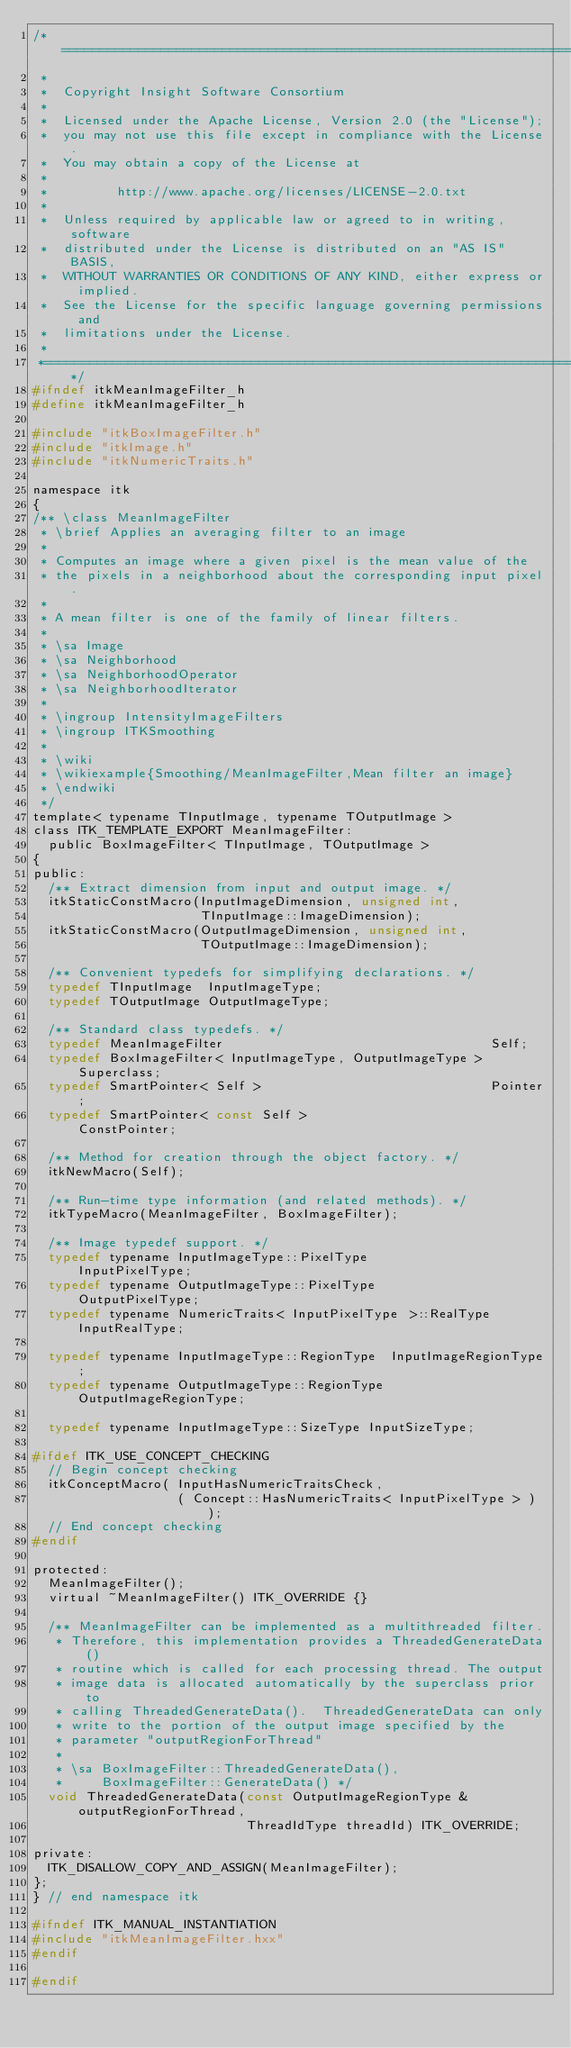<code> <loc_0><loc_0><loc_500><loc_500><_C_>/*=========================================================================
 *
 *  Copyright Insight Software Consortium
 *
 *  Licensed under the Apache License, Version 2.0 (the "License");
 *  you may not use this file except in compliance with the License.
 *  You may obtain a copy of the License at
 *
 *         http://www.apache.org/licenses/LICENSE-2.0.txt
 *
 *  Unless required by applicable law or agreed to in writing, software
 *  distributed under the License is distributed on an "AS IS" BASIS,
 *  WITHOUT WARRANTIES OR CONDITIONS OF ANY KIND, either express or implied.
 *  See the License for the specific language governing permissions and
 *  limitations under the License.
 *
 *=========================================================================*/
#ifndef itkMeanImageFilter_h
#define itkMeanImageFilter_h

#include "itkBoxImageFilter.h"
#include "itkImage.h"
#include "itkNumericTraits.h"

namespace itk
{
/** \class MeanImageFilter
 * \brief Applies an averaging filter to an image
 *
 * Computes an image where a given pixel is the mean value of the
 * the pixels in a neighborhood about the corresponding input pixel.
 *
 * A mean filter is one of the family of linear filters.
 *
 * \sa Image
 * \sa Neighborhood
 * \sa NeighborhoodOperator
 * \sa NeighborhoodIterator
 *
 * \ingroup IntensityImageFilters
 * \ingroup ITKSmoothing
 *
 * \wiki
 * \wikiexample{Smoothing/MeanImageFilter,Mean filter an image}
 * \endwiki
 */
template< typename TInputImage, typename TOutputImage >
class ITK_TEMPLATE_EXPORT MeanImageFilter:
  public BoxImageFilter< TInputImage, TOutputImage >
{
public:
  /** Extract dimension from input and output image. */
  itkStaticConstMacro(InputImageDimension, unsigned int,
                      TInputImage::ImageDimension);
  itkStaticConstMacro(OutputImageDimension, unsigned int,
                      TOutputImage::ImageDimension);

  /** Convenient typedefs for simplifying declarations. */
  typedef TInputImage  InputImageType;
  typedef TOutputImage OutputImageType;

  /** Standard class typedefs. */
  typedef MeanImageFilter                                   Self;
  typedef BoxImageFilter< InputImageType, OutputImageType > Superclass;
  typedef SmartPointer< Self >                              Pointer;
  typedef SmartPointer< const Self >                        ConstPointer;

  /** Method for creation through the object factory. */
  itkNewMacro(Self);

  /** Run-time type information (and related methods). */
  itkTypeMacro(MeanImageFilter, BoxImageFilter);

  /** Image typedef support. */
  typedef typename InputImageType::PixelType                 InputPixelType;
  typedef typename OutputImageType::PixelType                OutputPixelType;
  typedef typename NumericTraits< InputPixelType >::RealType InputRealType;

  typedef typename InputImageType::RegionType  InputImageRegionType;
  typedef typename OutputImageType::RegionType OutputImageRegionType;

  typedef typename InputImageType::SizeType InputSizeType;

#ifdef ITK_USE_CONCEPT_CHECKING
  // Begin concept checking
  itkConceptMacro( InputHasNumericTraitsCheck,
                   ( Concept::HasNumericTraits< InputPixelType > ) );
  // End concept checking
#endif

protected:
  MeanImageFilter();
  virtual ~MeanImageFilter() ITK_OVERRIDE {}

  /** MeanImageFilter can be implemented as a multithreaded filter.
   * Therefore, this implementation provides a ThreadedGenerateData()
   * routine which is called for each processing thread. The output
   * image data is allocated automatically by the superclass prior to
   * calling ThreadedGenerateData().  ThreadedGenerateData can only
   * write to the portion of the output image specified by the
   * parameter "outputRegionForThread"
   *
   * \sa BoxImageFilter::ThreadedGenerateData(),
   *     BoxImageFilter::GenerateData() */
  void ThreadedGenerateData(const OutputImageRegionType & outputRegionForThread,
                            ThreadIdType threadId) ITK_OVERRIDE;

private:
  ITK_DISALLOW_COPY_AND_ASSIGN(MeanImageFilter);
};
} // end namespace itk

#ifndef ITK_MANUAL_INSTANTIATION
#include "itkMeanImageFilter.hxx"
#endif

#endif
</code> 